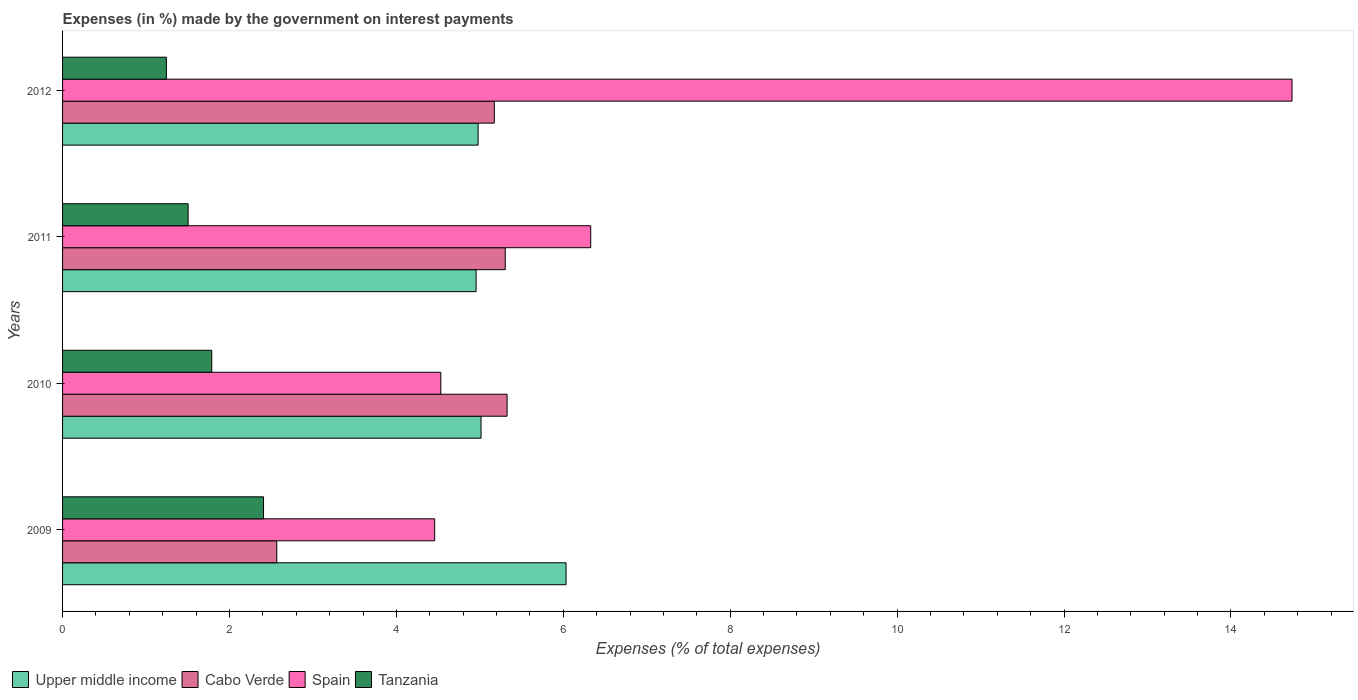How many groups of bars are there?
Provide a succinct answer. 4. Are the number of bars on each tick of the Y-axis equal?
Provide a succinct answer. Yes. How many bars are there on the 1st tick from the bottom?
Give a very brief answer. 4. What is the percentage of expenses made by the government on interest payments in Tanzania in 2012?
Keep it short and to the point. 1.24. Across all years, what is the maximum percentage of expenses made by the government on interest payments in Cabo Verde?
Your answer should be very brief. 5.33. Across all years, what is the minimum percentage of expenses made by the government on interest payments in Spain?
Provide a short and direct response. 4.46. In which year was the percentage of expenses made by the government on interest payments in Cabo Verde minimum?
Give a very brief answer. 2009. What is the total percentage of expenses made by the government on interest payments in Cabo Verde in the graph?
Your answer should be very brief. 18.37. What is the difference between the percentage of expenses made by the government on interest payments in Spain in 2010 and that in 2011?
Provide a succinct answer. -1.8. What is the difference between the percentage of expenses made by the government on interest payments in Spain in 2009 and the percentage of expenses made by the government on interest payments in Upper middle income in 2012?
Offer a terse response. -0.52. What is the average percentage of expenses made by the government on interest payments in Upper middle income per year?
Ensure brevity in your answer.  5.25. In the year 2012, what is the difference between the percentage of expenses made by the government on interest payments in Tanzania and percentage of expenses made by the government on interest payments in Cabo Verde?
Keep it short and to the point. -3.93. In how many years, is the percentage of expenses made by the government on interest payments in Upper middle income greater than 2 %?
Offer a very short reply. 4. What is the ratio of the percentage of expenses made by the government on interest payments in Upper middle income in 2010 to that in 2012?
Provide a succinct answer. 1.01. What is the difference between the highest and the second highest percentage of expenses made by the government on interest payments in Cabo Verde?
Ensure brevity in your answer.  0.02. What is the difference between the highest and the lowest percentage of expenses made by the government on interest payments in Tanzania?
Provide a succinct answer. 1.16. What does the 4th bar from the top in 2012 represents?
Your answer should be compact. Upper middle income. Is it the case that in every year, the sum of the percentage of expenses made by the government on interest payments in Tanzania and percentage of expenses made by the government on interest payments in Spain is greater than the percentage of expenses made by the government on interest payments in Upper middle income?
Offer a very short reply. Yes. How many bars are there?
Keep it short and to the point. 16. How many years are there in the graph?
Your response must be concise. 4. What is the difference between two consecutive major ticks on the X-axis?
Offer a very short reply. 2. Does the graph contain grids?
Provide a succinct answer. No. Where does the legend appear in the graph?
Your response must be concise. Bottom left. How are the legend labels stacked?
Keep it short and to the point. Horizontal. What is the title of the graph?
Keep it short and to the point. Expenses (in %) made by the government on interest payments. What is the label or title of the X-axis?
Your response must be concise. Expenses (% of total expenses). What is the Expenses (% of total expenses) in Upper middle income in 2009?
Provide a short and direct response. 6.03. What is the Expenses (% of total expenses) in Cabo Verde in 2009?
Your answer should be very brief. 2.57. What is the Expenses (% of total expenses) in Spain in 2009?
Your answer should be compact. 4.46. What is the Expenses (% of total expenses) in Tanzania in 2009?
Your response must be concise. 2.41. What is the Expenses (% of total expenses) in Upper middle income in 2010?
Offer a very short reply. 5.01. What is the Expenses (% of total expenses) of Cabo Verde in 2010?
Your answer should be very brief. 5.33. What is the Expenses (% of total expenses) of Spain in 2010?
Offer a terse response. 4.53. What is the Expenses (% of total expenses) in Tanzania in 2010?
Keep it short and to the point. 1.79. What is the Expenses (% of total expenses) in Upper middle income in 2011?
Provide a succinct answer. 4.96. What is the Expenses (% of total expenses) of Cabo Verde in 2011?
Provide a short and direct response. 5.3. What is the Expenses (% of total expenses) of Spain in 2011?
Ensure brevity in your answer.  6.33. What is the Expenses (% of total expenses) in Tanzania in 2011?
Offer a terse response. 1.5. What is the Expenses (% of total expenses) in Upper middle income in 2012?
Offer a very short reply. 4.98. What is the Expenses (% of total expenses) of Cabo Verde in 2012?
Provide a succinct answer. 5.17. What is the Expenses (% of total expenses) in Spain in 2012?
Keep it short and to the point. 14.73. What is the Expenses (% of total expenses) of Tanzania in 2012?
Provide a short and direct response. 1.24. Across all years, what is the maximum Expenses (% of total expenses) of Upper middle income?
Provide a succinct answer. 6.03. Across all years, what is the maximum Expenses (% of total expenses) of Cabo Verde?
Offer a very short reply. 5.33. Across all years, what is the maximum Expenses (% of total expenses) in Spain?
Provide a short and direct response. 14.73. Across all years, what is the maximum Expenses (% of total expenses) in Tanzania?
Offer a very short reply. 2.41. Across all years, what is the minimum Expenses (% of total expenses) in Upper middle income?
Keep it short and to the point. 4.96. Across all years, what is the minimum Expenses (% of total expenses) in Cabo Verde?
Offer a terse response. 2.57. Across all years, what is the minimum Expenses (% of total expenses) of Spain?
Offer a terse response. 4.46. Across all years, what is the minimum Expenses (% of total expenses) in Tanzania?
Ensure brevity in your answer.  1.24. What is the total Expenses (% of total expenses) in Upper middle income in the graph?
Offer a very short reply. 20.98. What is the total Expenses (% of total expenses) in Cabo Verde in the graph?
Keep it short and to the point. 18.37. What is the total Expenses (% of total expenses) of Spain in the graph?
Your response must be concise. 30.05. What is the total Expenses (% of total expenses) in Tanzania in the graph?
Make the answer very short. 6.94. What is the difference between the Expenses (% of total expenses) in Upper middle income in 2009 and that in 2010?
Your answer should be compact. 1.02. What is the difference between the Expenses (% of total expenses) in Cabo Verde in 2009 and that in 2010?
Offer a terse response. -2.76. What is the difference between the Expenses (% of total expenses) of Spain in 2009 and that in 2010?
Your response must be concise. -0.07. What is the difference between the Expenses (% of total expenses) of Tanzania in 2009 and that in 2010?
Provide a short and direct response. 0.62. What is the difference between the Expenses (% of total expenses) of Upper middle income in 2009 and that in 2011?
Provide a short and direct response. 1.08. What is the difference between the Expenses (% of total expenses) in Cabo Verde in 2009 and that in 2011?
Your answer should be very brief. -2.74. What is the difference between the Expenses (% of total expenses) in Spain in 2009 and that in 2011?
Provide a succinct answer. -1.87. What is the difference between the Expenses (% of total expenses) in Tanzania in 2009 and that in 2011?
Make the answer very short. 0.9. What is the difference between the Expenses (% of total expenses) of Upper middle income in 2009 and that in 2012?
Offer a terse response. 1.05. What is the difference between the Expenses (% of total expenses) in Cabo Verde in 2009 and that in 2012?
Give a very brief answer. -2.61. What is the difference between the Expenses (% of total expenses) of Spain in 2009 and that in 2012?
Offer a terse response. -10.27. What is the difference between the Expenses (% of total expenses) of Tanzania in 2009 and that in 2012?
Give a very brief answer. 1.16. What is the difference between the Expenses (% of total expenses) of Upper middle income in 2010 and that in 2011?
Keep it short and to the point. 0.06. What is the difference between the Expenses (% of total expenses) of Cabo Verde in 2010 and that in 2011?
Offer a terse response. 0.02. What is the difference between the Expenses (% of total expenses) in Spain in 2010 and that in 2011?
Make the answer very short. -1.8. What is the difference between the Expenses (% of total expenses) in Tanzania in 2010 and that in 2011?
Provide a short and direct response. 0.28. What is the difference between the Expenses (% of total expenses) in Upper middle income in 2010 and that in 2012?
Provide a short and direct response. 0.03. What is the difference between the Expenses (% of total expenses) of Cabo Verde in 2010 and that in 2012?
Your answer should be very brief. 0.15. What is the difference between the Expenses (% of total expenses) of Spain in 2010 and that in 2012?
Give a very brief answer. -10.2. What is the difference between the Expenses (% of total expenses) of Tanzania in 2010 and that in 2012?
Provide a succinct answer. 0.54. What is the difference between the Expenses (% of total expenses) of Upper middle income in 2011 and that in 2012?
Ensure brevity in your answer.  -0.02. What is the difference between the Expenses (% of total expenses) in Cabo Verde in 2011 and that in 2012?
Your answer should be very brief. 0.13. What is the difference between the Expenses (% of total expenses) in Spain in 2011 and that in 2012?
Make the answer very short. -8.4. What is the difference between the Expenses (% of total expenses) of Tanzania in 2011 and that in 2012?
Your response must be concise. 0.26. What is the difference between the Expenses (% of total expenses) of Upper middle income in 2009 and the Expenses (% of total expenses) of Cabo Verde in 2010?
Provide a short and direct response. 0.71. What is the difference between the Expenses (% of total expenses) of Upper middle income in 2009 and the Expenses (% of total expenses) of Spain in 2010?
Give a very brief answer. 1.5. What is the difference between the Expenses (% of total expenses) of Upper middle income in 2009 and the Expenses (% of total expenses) of Tanzania in 2010?
Give a very brief answer. 4.25. What is the difference between the Expenses (% of total expenses) in Cabo Verde in 2009 and the Expenses (% of total expenses) in Spain in 2010?
Your response must be concise. -1.97. What is the difference between the Expenses (% of total expenses) in Cabo Verde in 2009 and the Expenses (% of total expenses) in Tanzania in 2010?
Ensure brevity in your answer.  0.78. What is the difference between the Expenses (% of total expenses) of Spain in 2009 and the Expenses (% of total expenses) of Tanzania in 2010?
Offer a very short reply. 2.67. What is the difference between the Expenses (% of total expenses) of Upper middle income in 2009 and the Expenses (% of total expenses) of Cabo Verde in 2011?
Ensure brevity in your answer.  0.73. What is the difference between the Expenses (% of total expenses) in Upper middle income in 2009 and the Expenses (% of total expenses) in Spain in 2011?
Your answer should be very brief. -0.3. What is the difference between the Expenses (% of total expenses) in Upper middle income in 2009 and the Expenses (% of total expenses) in Tanzania in 2011?
Give a very brief answer. 4.53. What is the difference between the Expenses (% of total expenses) of Cabo Verde in 2009 and the Expenses (% of total expenses) of Spain in 2011?
Your response must be concise. -3.76. What is the difference between the Expenses (% of total expenses) of Cabo Verde in 2009 and the Expenses (% of total expenses) of Tanzania in 2011?
Offer a terse response. 1.06. What is the difference between the Expenses (% of total expenses) of Spain in 2009 and the Expenses (% of total expenses) of Tanzania in 2011?
Provide a short and direct response. 2.95. What is the difference between the Expenses (% of total expenses) in Upper middle income in 2009 and the Expenses (% of total expenses) in Cabo Verde in 2012?
Ensure brevity in your answer.  0.86. What is the difference between the Expenses (% of total expenses) of Upper middle income in 2009 and the Expenses (% of total expenses) of Spain in 2012?
Ensure brevity in your answer.  -8.7. What is the difference between the Expenses (% of total expenses) in Upper middle income in 2009 and the Expenses (% of total expenses) in Tanzania in 2012?
Your answer should be compact. 4.79. What is the difference between the Expenses (% of total expenses) in Cabo Verde in 2009 and the Expenses (% of total expenses) in Spain in 2012?
Provide a succinct answer. -12.16. What is the difference between the Expenses (% of total expenses) of Cabo Verde in 2009 and the Expenses (% of total expenses) of Tanzania in 2012?
Your response must be concise. 1.32. What is the difference between the Expenses (% of total expenses) in Spain in 2009 and the Expenses (% of total expenses) in Tanzania in 2012?
Your response must be concise. 3.21. What is the difference between the Expenses (% of total expenses) of Upper middle income in 2010 and the Expenses (% of total expenses) of Cabo Verde in 2011?
Provide a succinct answer. -0.29. What is the difference between the Expenses (% of total expenses) in Upper middle income in 2010 and the Expenses (% of total expenses) in Spain in 2011?
Offer a very short reply. -1.31. What is the difference between the Expenses (% of total expenses) in Upper middle income in 2010 and the Expenses (% of total expenses) in Tanzania in 2011?
Provide a short and direct response. 3.51. What is the difference between the Expenses (% of total expenses) of Cabo Verde in 2010 and the Expenses (% of total expenses) of Spain in 2011?
Your response must be concise. -1. What is the difference between the Expenses (% of total expenses) of Cabo Verde in 2010 and the Expenses (% of total expenses) of Tanzania in 2011?
Your response must be concise. 3.82. What is the difference between the Expenses (% of total expenses) in Spain in 2010 and the Expenses (% of total expenses) in Tanzania in 2011?
Provide a succinct answer. 3.03. What is the difference between the Expenses (% of total expenses) of Upper middle income in 2010 and the Expenses (% of total expenses) of Cabo Verde in 2012?
Make the answer very short. -0.16. What is the difference between the Expenses (% of total expenses) of Upper middle income in 2010 and the Expenses (% of total expenses) of Spain in 2012?
Make the answer very short. -9.72. What is the difference between the Expenses (% of total expenses) in Upper middle income in 2010 and the Expenses (% of total expenses) in Tanzania in 2012?
Provide a succinct answer. 3.77. What is the difference between the Expenses (% of total expenses) in Cabo Verde in 2010 and the Expenses (% of total expenses) in Spain in 2012?
Provide a short and direct response. -9.41. What is the difference between the Expenses (% of total expenses) of Cabo Verde in 2010 and the Expenses (% of total expenses) of Tanzania in 2012?
Offer a terse response. 4.08. What is the difference between the Expenses (% of total expenses) in Spain in 2010 and the Expenses (% of total expenses) in Tanzania in 2012?
Provide a short and direct response. 3.29. What is the difference between the Expenses (% of total expenses) in Upper middle income in 2011 and the Expenses (% of total expenses) in Cabo Verde in 2012?
Offer a very short reply. -0.22. What is the difference between the Expenses (% of total expenses) in Upper middle income in 2011 and the Expenses (% of total expenses) in Spain in 2012?
Make the answer very short. -9.78. What is the difference between the Expenses (% of total expenses) in Upper middle income in 2011 and the Expenses (% of total expenses) in Tanzania in 2012?
Provide a succinct answer. 3.71. What is the difference between the Expenses (% of total expenses) of Cabo Verde in 2011 and the Expenses (% of total expenses) of Spain in 2012?
Your answer should be compact. -9.43. What is the difference between the Expenses (% of total expenses) of Cabo Verde in 2011 and the Expenses (% of total expenses) of Tanzania in 2012?
Ensure brevity in your answer.  4.06. What is the difference between the Expenses (% of total expenses) of Spain in 2011 and the Expenses (% of total expenses) of Tanzania in 2012?
Offer a very short reply. 5.08. What is the average Expenses (% of total expenses) of Upper middle income per year?
Offer a terse response. 5.25. What is the average Expenses (% of total expenses) of Cabo Verde per year?
Ensure brevity in your answer.  4.59. What is the average Expenses (% of total expenses) in Spain per year?
Make the answer very short. 7.51. What is the average Expenses (% of total expenses) in Tanzania per year?
Your answer should be compact. 1.74. In the year 2009, what is the difference between the Expenses (% of total expenses) of Upper middle income and Expenses (% of total expenses) of Cabo Verde?
Offer a very short reply. 3.47. In the year 2009, what is the difference between the Expenses (% of total expenses) of Upper middle income and Expenses (% of total expenses) of Spain?
Ensure brevity in your answer.  1.57. In the year 2009, what is the difference between the Expenses (% of total expenses) in Upper middle income and Expenses (% of total expenses) in Tanzania?
Offer a terse response. 3.62. In the year 2009, what is the difference between the Expenses (% of total expenses) in Cabo Verde and Expenses (% of total expenses) in Spain?
Keep it short and to the point. -1.89. In the year 2009, what is the difference between the Expenses (% of total expenses) of Cabo Verde and Expenses (% of total expenses) of Tanzania?
Keep it short and to the point. 0.16. In the year 2009, what is the difference between the Expenses (% of total expenses) of Spain and Expenses (% of total expenses) of Tanzania?
Make the answer very short. 2.05. In the year 2010, what is the difference between the Expenses (% of total expenses) of Upper middle income and Expenses (% of total expenses) of Cabo Verde?
Your answer should be compact. -0.31. In the year 2010, what is the difference between the Expenses (% of total expenses) of Upper middle income and Expenses (% of total expenses) of Spain?
Offer a very short reply. 0.48. In the year 2010, what is the difference between the Expenses (% of total expenses) of Upper middle income and Expenses (% of total expenses) of Tanzania?
Ensure brevity in your answer.  3.23. In the year 2010, what is the difference between the Expenses (% of total expenses) in Cabo Verde and Expenses (% of total expenses) in Spain?
Keep it short and to the point. 0.79. In the year 2010, what is the difference between the Expenses (% of total expenses) of Cabo Verde and Expenses (% of total expenses) of Tanzania?
Offer a terse response. 3.54. In the year 2010, what is the difference between the Expenses (% of total expenses) in Spain and Expenses (% of total expenses) in Tanzania?
Keep it short and to the point. 2.74. In the year 2011, what is the difference between the Expenses (% of total expenses) in Upper middle income and Expenses (% of total expenses) in Cabo Verde?
Give a very brief answer. -0.35. In the year 2011, what is the difference between the Expenses (% of total expenses) of Upper middle income and Expenses (% of total expenses) of Spain?
Keep it short and to the point. -1.37. In the year 2011, what is the difference between the Expenses (% of total expenses) of Upper middle income and Expenses (% of total expenses) of Tanzania?
Your answer should be compact. 3.45. In the year 2011, what is the difference between the Expenses (% of total expenses) in Cabo Verde and Expenses (% of total expenses) in Spain?
Offer a terse response. -1.02. In the year 2011, what is the difference between the Expenses (% of total expenses) in Cabo Verde and Expenses (% of total expenses) in Tanzania?
Provide a short and direct response. 3.8. In the year 2011, what is the difference between the Expenses (% of total expenses) in Spain and Expenses (% of total expenses) in Tanzania?
Keep it short and to the point. 4.82. In the year 2012, what is the difference between the Expenses (% of total expenses) in Upper middle income and Expenses (% of total expenses) in Cabo Verde?
Offer a very short reply. -0.19. In the year 2012, what is the difference between the Expenses (% of total expenses) of Upper middle income and Expenses (% of total expenses) of Spain?
Give a very brief answer. -9.75. In the year 2012, what is the difference between the Expenses (% of total expenses) of Upper middle income and Expenses (% of total expenses) of Tanzania?
Make the answer very short. 3.74. In the year 2012, what is the difference between the Expenses (% of total expenses) of Cabo Verde and Expenses (% of total expenses) of Spain?
Make the answer very short. -9.56. In the year 2012, what is the difference between the Expenses (% of total expenses) of Cabo Verde and Expenses (% of total expenses) of Tanzania?
Provide a short and direct response. 3.93. In the year 2012, what is the difference between the Expenses (% of total expenses) of Spain and Expenses (% of total expenses) of Tanzania?
Make the answer very short. 13.49. What is the ratio of the Expenses (% of total expenses) in Upper middle income in 2009 to that in 2010?
Make the answer very short. 1.2. What is the ratio of the Expenses (% of total expenses) of Cabo Verde in 2009 to that in 2010?
Provide a short and direct response. 0.48. What is the ratio of the Expenses (% of total expenses) in Spain in 2009 to that in 2010?
Provide a succinct answer. 0.98. What is the ratio of the Expenses (% of total expenses) in Tanzania in 2009 to that in 2010?
Offer a terse response. 1.35. What is the ratio of the Expenses (% of total expenses) of Upper middle income in 2009 to that in 2011?
Your answer should be very brief. 1.22. What is the ratio of the Expenses (% of total expenses) in Cabo Verde in 2009 to that in 2011?
Provide a short and direct response. 0.48. What is the ratio of the Expenses (% of total expenses) in Spain in 2009 to that in 2011?
Provide a short and direct response. 0.7. What is the ratio of the Expenses (% of total expenses) in Tanzania in 2009 to that in 2011?
Offer a very short reply. 1.6. What is the ratio of the Expenses (% of total expenses) in Upper middle income in 2009 to that in 2012?
Give a very brief answer. 1.21. What is the ratio of the Expenses (% of total expenses) of Cabo Verde in 2009 to that in 2012?
Your response must be concise. 0.5. What is the ratio of the Expenses (% of total expenses) in Spain in 2009 to that in 2012?
Your answer should be very brief. 0.3. What is the ratio of the Expenses (% of total expenses) of Tanzania in 2009 to that in 2012?
Offer a terse response. 1.94. What is the ratio of the Expenses (% of total expenses) in Upper middle income in 2010 to that in 2011?
Offer a terse response. 1.01. What is the ratio of the Expenses (% of total expenses) of Cabo Verde in 2010 to that in 2011?
Your answer should be compact. 1. What is the ratio of the Expenses (% of total expenses) in Spain in 2010 to that in 2011?
Provide a succinct answer. 0.72. What is the ratio of the Expenses (% of total expenses) of Tanzania in 2010 to that in 2011?
Your answer should be very brief. 1.19. What is the ratio of the Expenses (% of total expenses) in Upper middle income in 2010 to that in 2012?
Make the answer very short. 1.01. What is the ratio of the Expenses (% of total expenses) in Cabo Verde in 2010 to that in 2012?
Offer a very short reply. 1.03. What is the ratio of the Expenses (% of total expenses) in Spain in 2010 to that in 2012?
Your answer should be very brief. 0.31. What is the ratio of the Expenses (% of total expenses) of Tanzania in 2010 to that in 2012?
Provide a short and direct response. 1.44. What is the ratio of the Expenses (% of total expenses) in Cabo Verde in 2011 to that in 2012?
Make the answer very short. 1.03. What is the ratio of the Expenses (% of total expenses) in Spain in 2011 to that in 2012?
Your answer should be compact. 0.43. What is the ratio of the Expenses (% of total expenses) of Tanzania in 2011 to that in 2012?
Ensure brevity in your answer.  1.21. What is the difference between the highest and the second highest Expenses (% of total expenses) in Upper middle income?
Your response must be concise. 1.02. What is the difference between the highest and the second highest Expenses (% of total expenses) of Cabo Verde?
Provide a short and direct response. 0.02. What is the difference between the highest and the second highest Expenses (% of total expenses) in Spain?
Ensure brevity in your answer.  8.4. What is the difference between the highest and the second highest Expenses (% of total expenses) of Tanzania?
Offer a terse response. 0.62. What is the difference between the highest and the lowest Expenses (% of total expenses) of Upper middle income?
Your answer should be compact. 1.08. What is the difference between the highest and the lowest Expenses (% of total expenses) in Cabo Verde?
Keep it short and to the point. 2.76. What is the difference between the highest and the lowest Expenses (% of total expenses) in Spain?
Your response must be concise. 10.27. What is the difference between the highest and the lowest Expenses (% of total expenses) of Tanzania?
Give a very brief answer. 1.16. 